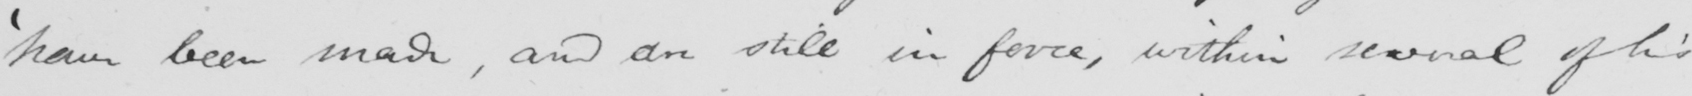Transcribe the text shown in this historical manuscript line. ' have been made , and are still in force , within several of his 